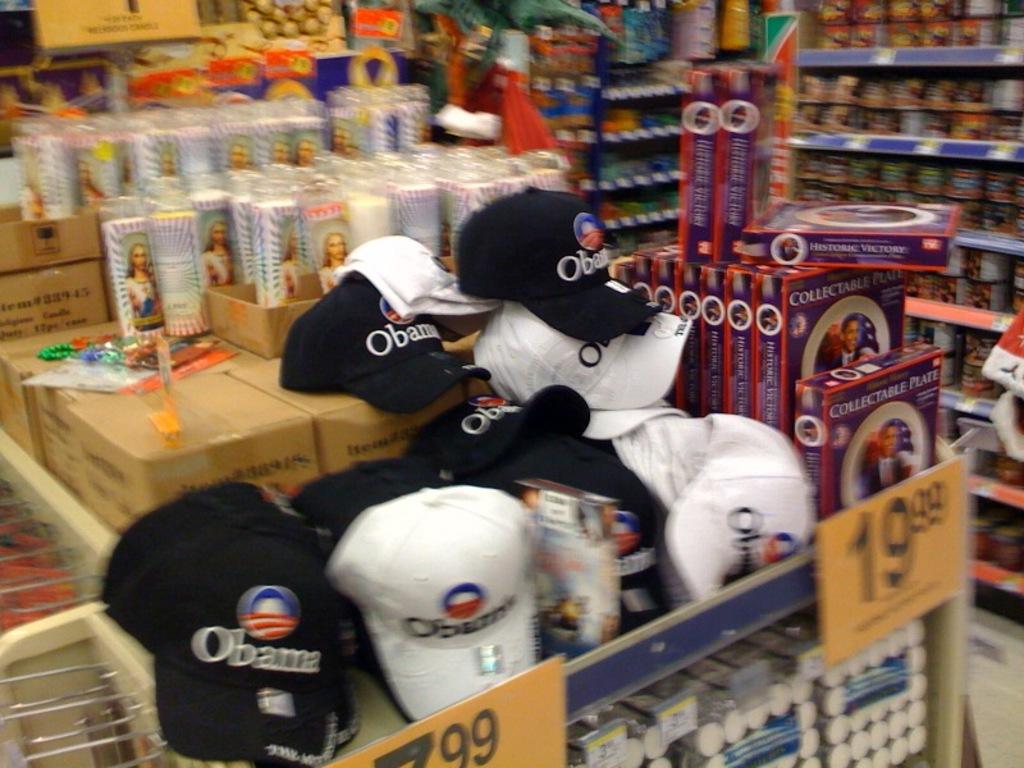What is written on the hats?
Give a very brief answer. Obama. 